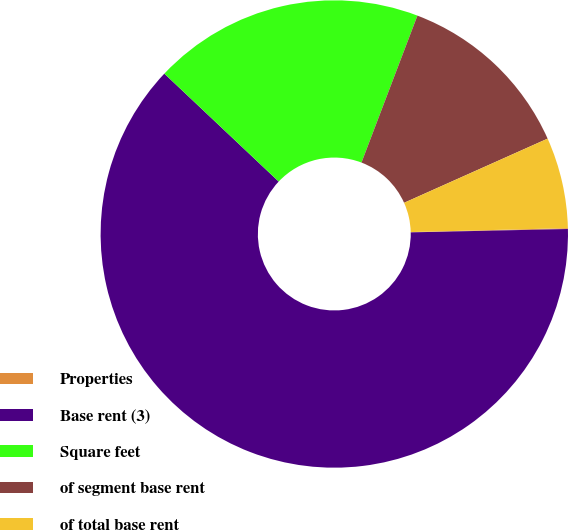<chart> <loc_0><loc_0><loc_500><loc_500><pie_chart><fcel>Properties<fcel>Base rent (3)<fcel>Square feet<fcel>of segment base rent<fcel>of total base rent<nl><fcel>0.06%<fcel>62.38%<fcel>18.75%<fcel>12.52%<fcel>6.29%<nl></chart> 